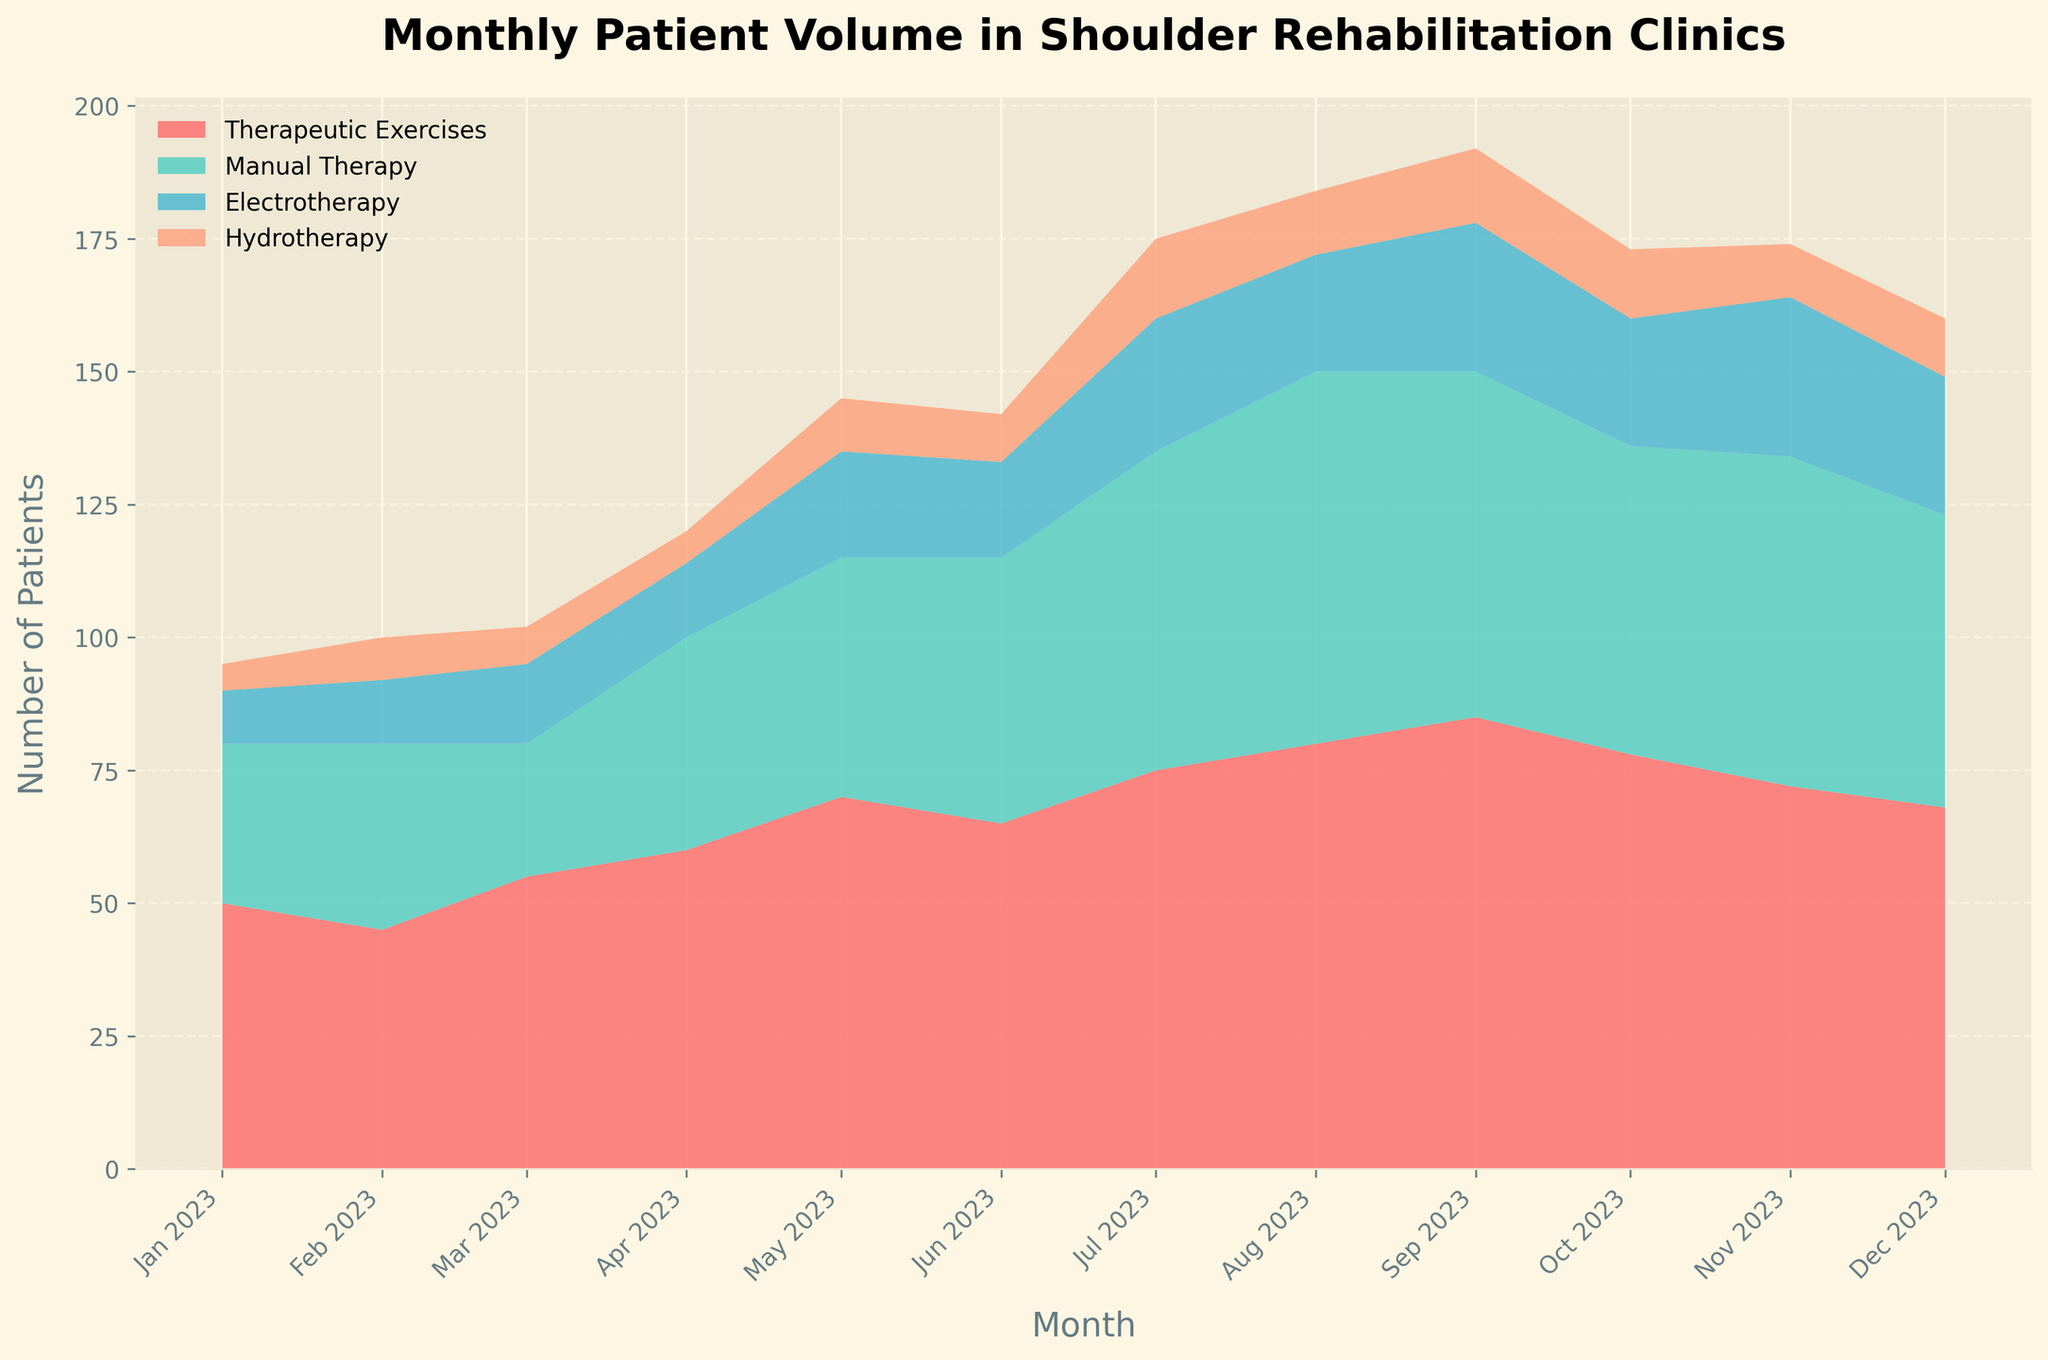What is the title of the figure? The title of the figure is usually located at the top of the chart and is meant to provide an overview of what the data represents. Here, the title is clearly visible as 'Monthly Patient Volume in Shoulder Rehabilitation Clinics'.
Answer: Monthly Patient Volume in Shoulder Rehabilitation Clinics What treatments are represented in the area chart? The legend on the chart shows the different treatments represented. According to this legend, the treatments are Therapeutic Exercises, Manual Therapy, Electrotherapy, and Hydrotherapy.
Answer: Therapeutic Exercises, Manual Therapy, Electrotherapy, Hydrotherapy Which treatment had the highest number of patients in July 2023? To determine the highest number of patients in July 2023, locate July 2023 on the X-axis and check which area has the largest contribution. Based on the colors and the heights of the sections, we see that Therapeutic Exercises had the largest number of patients.
Answer: Therapeutic Exercises How did the patient volume for Hydrotherapy change from January 2023 to December 2023? By examining the area corresponding to Hydrotherapy (denoted by its specific color) from January to December 2023, it's clear that the volume started at 5 patients and ended at 11 patients, increasing over the period.
Answer: Increased What month had the highest total patient volume? To find the month with the highest total patient volume, observe the combined heights of the stacked areas for each month. It is clear from the overall height that August 2023 had the highest total patient volume.
Answer: August 2023 Which treatment shows the most consistent patient volume throughout the year? The consistency can be judged by the uniformity of the width across the months. Manual Therapy shows the most consistent patient volume, as its area does not vary as widely compared to others.
Answer: Manual Therapy In which month did Electrotherapy see its highest number of patients? Look at the Electrotherapy area only and identify the peak month. The tallest section for Electrotherapy is in November 2023.
Answer: November 2023 Compare the patient volume between Therapeutic Exercises and Manual Therapy in October 2023. For October 2023, identify the boundaries for both treatments on the stacked areas. Therapeutic Exercises clearly have a larger area compared to Manual Therapy in this month.
Answer: Therapeutic Exercises > Manual Therapy What is the total patient volume for June 2023? To get the total, sum up the values for all treatments in June 2023: 65 (Therapeutic Exercises) + 50 (Manual Therapy) + 18 (Electrotherapy) + 9 (Hydrotherapy) = 142 patients.
Answer: 142 Between which two consecutive months was the largest increase in patient volume observed? By comparing the total heights of the stacked areas between consecutive months, the largest increase occurs between February 2023 and March 2023.
Answer: February to March 